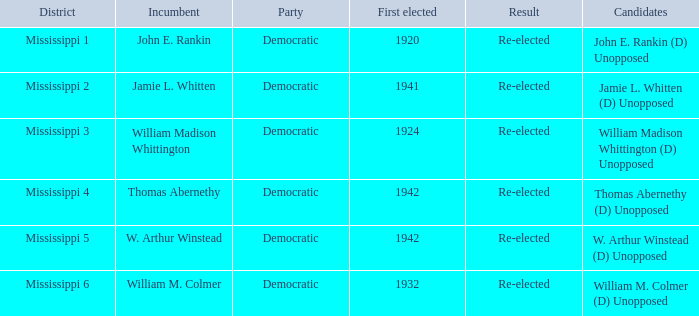Which district is jamie l. whitten from? Mississippi 2. 